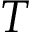<formula> <loc_0><loc_0><loc_500><loc_500>T</formula> 